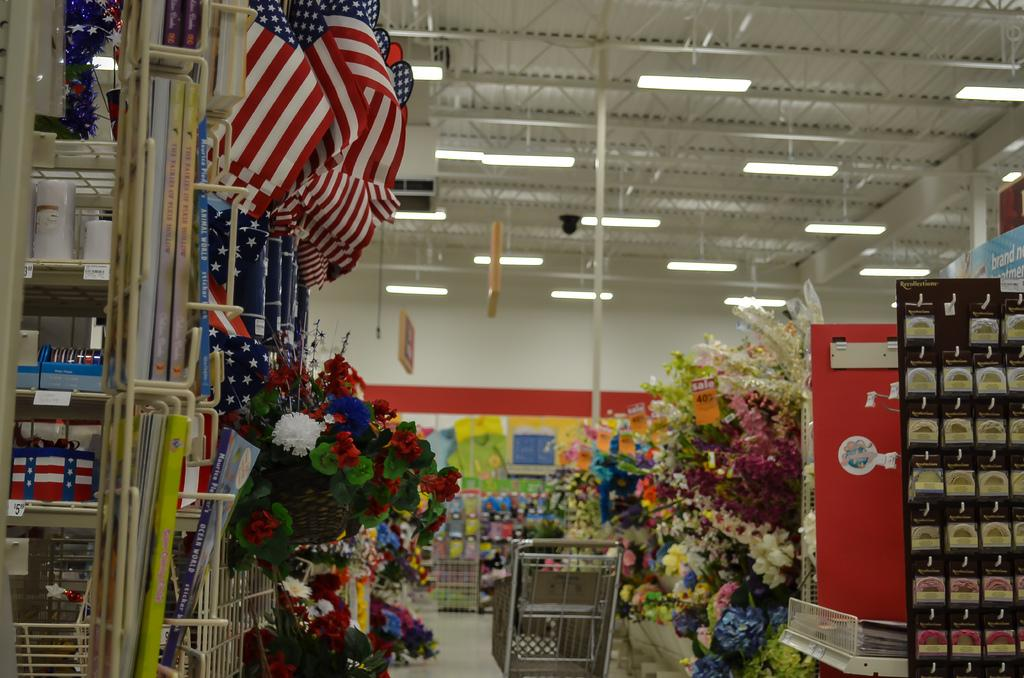What can be seen in the image that represents a symbol or country? There are flags in the image. What items in the image might be used for decoration or gifting? There are bouquets in the image. What items in the image might be used for reading or learning? There are books in the image. What type of furniture is present in the image? There are racks in the image. What is located beside the racks in the image? There is a cart beside the racks. What type of structures can be seen in the background of the image? There are metal rods and lights in the background of the image. What type of fuel is being used by the rod in the image? There is no rod or fuel present in the image. What type of underwear is hanging on the metal rods in the image? There are no undergarments or metal rods visible in the image. 